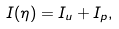Convert formula to latex. <formula><loc_0><loc_0><loc_500><loc_500>I ( \eta ) = I _ { u } + I _ { p } ,</formula> 